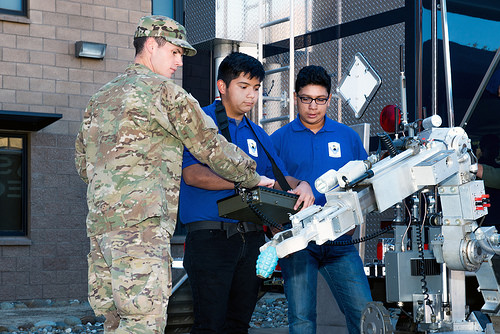<image>
Is the robot behind the man? No. The robot is not behind the man. From this viewpoint, the robot appears to be positioned elsewhere in the scene. Is there a man next to the soldier? No. The man is not positioned next to the soldier. They are located in different areas of the scene. Is there a computer in front of the man? Yes. The computer is positioned in front of the man, appearing closer to the camera viewpoint. 